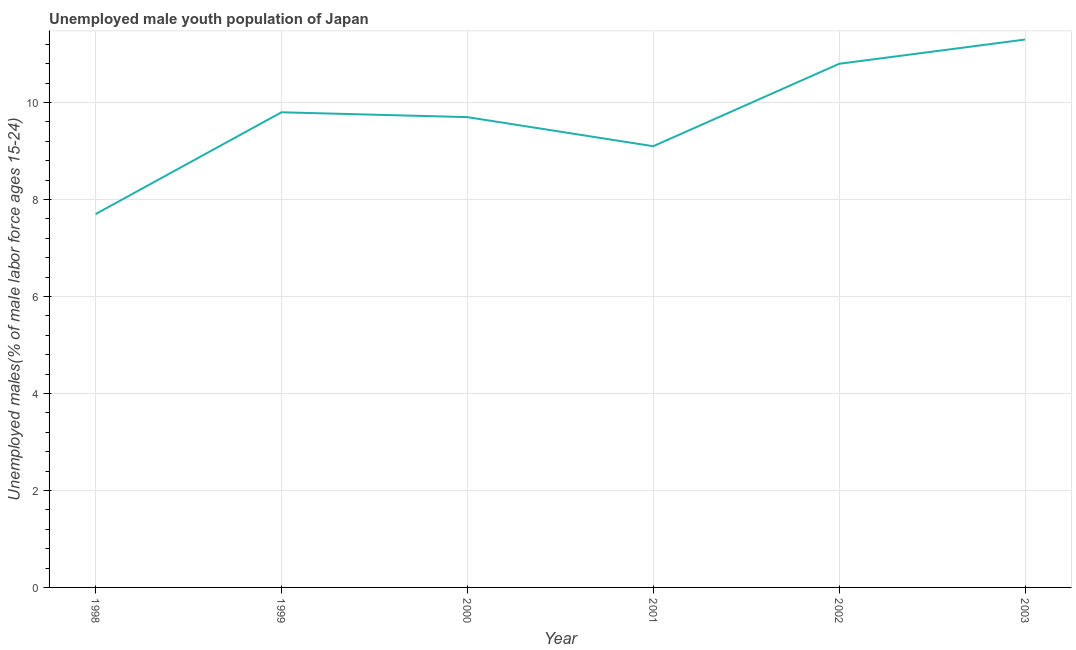What is the unemployed male youth in 2000?
Provide a short and direct response. 9.7. Across all years, what is the maximum unemployed male youth?
Keep it short and to the point. 11.3. Across all years, what is the minimum unemployed male youth?
Offer a terse response. 7.7. In which year was the unemployed male youth maximum?
Offer a terse response. 2003. In which year was the unemployed male youth minimum?
Make the answer very short. 1998. What is the sum of the unemployed male youth?
Provide a short and direct response. 58.4. What is the difference between the unemployed male youth in 1998 and 2000?
Provide a short and direct response. -2. What is the average unemployed male youth per year?
Your response must be concise. 9.73. What is the median unemployed male youth?
Give a very brief answer. 9.75. In how many years, is the unemployed male youth greater than 0.4 %?
Your response must be concise. 6. Do a majority of the years between 1999 and 2002 (inclusive) have unemployed male youth greater than 8.4 %?
Ensure brevity in your answer.  Yes. What is the ratio of the unemployed male youth in 2000 to that in 2002?
Provide a short and direct response. 0.9. Is the difference between the unemployed male youth in 2000 and 2002 greater than the difference between any two years?
Ensure brevity in your answer.  No. Is the sum of the unemployed male youth in 2000 and 2002 greater than the maximum unemployed male youth across all years?
Ensure brevity in your answer.  Yes. What is the difference between the highest and the lowest unemployed male youth?
Ensure brevity in your answer.  3.6. How many lines are there?
Your answer should be compact. 1. How many years are there in the graph?
Provide a succinct answer. 6. Are the values on the major ticks of Y-axis written in scientific E-notation?
Make the answer very short. No. Does the graph contain grids?
Provide a short and direct response. Yes. What is the title of the graph?
Offer a terse response. Unemployed male youth population of Japan. What is the label or title of the X-axis?
Your response must be concise. Year. What is the label or title of the Y-axis?
Provide a succinct answer. Unemployed males(% of male labor force ages 15-24). What is the Unemployed males(% of male labor force ages 15-24) of 1998?
Make the answer very short. 7.7. What is the Unemployed males(% of male labor force ages 15-24) in 1999?
Provide a succinct answer. 9.8. What is the Unemployed males(% of male labor force ages 15-24) of 2000?
Provide a succinct answer. 9.7. What is the Unemployed males(% of male labor force ages 15-24) in 2001?
Your answer should be compact. 9.1. What is the Unemployed males(% of male labor force ages 15-24) of 2002?
Your answer should be compact. 10.8. What is the Unemployed males(% of male labor force ages 15-24) of 2003?
Provide a short and direct response. 11.3. What is the difference between the Unemployed males(% of male labor force ages 15-24) in 1998 and 2000?
Your answer should be very brief. -2. What is the difference between the Unemployed males(% of male labor force ages 15-24) in 1998 and 2001?
Offer a very short reply. -1.4. What is the difference between the Unemployed males(% of male labor force ages 15-24) in 1998 and 2003?
Ensure brevity in your answer.  -3.6. What is the difference between the Unemployed males(% of male labor force ages 15-24) in 1999 and 2001?
Give a very brief answer. 0.7. What is the difference between the Unemployed males(% of male labor force ages 15-24) in 1999 and 2003?
Give a very brief answer. -1.5. What is the difference between the Unemployed males(% of male labor force ages 15-24) in 2000 and 2001?
Ensure brevity in your answer.  0.6. What is the difference between the Unemployed males(% of male labor force ages 15-24) in 2002 and 2003?
Give a very brief answer. -0.5. What is the ratio of the Unemployed males(% of male labor force ages 15-24) in 1998 to that in 1999?
Provide a short and direct response. 0.79. What is the ratio of the Unemployed males(% of male labor force ages 15-24) in 1998 to that in 2000?
Keep it short and to the point. 0.79. What is the ratio of the Unemployed males(% of male labor force ages 15-24) in 1998 to that in 2001?
Make the answer very short. 0.85. What is the ratio of the Unemployed males(% of male labor force ages 15-24) in 1998 to that in 2002?
Ensure brevity in your answer.  0.71. What is the ratio of the Unemployed males(% of male labor force ages 15-24) in 1998 to that in 2003?
Provide a short and direct response. 0.68. What is the ratio of the Unemployed males(% of male labor force ages 15-24) in 1999 to that in 2000?
Provide a succinct answer. 1.01. What is the ratio of the Unemployed males(% of male labor force ages 15-24) in 1999 to that in 2001?
Your answer should be very brief. 1.08. What is the ratio of the Unemployed males(% of male labor force ages 15-24) in 1999 to that in 2002?
Your answer should be compact. 0.91. What is the ratio of the Unemployed males(% of male labor force ages 15-24) in 1999 to that in 2003?
Your answer should be very brief. 0.87. What is the ratio of the Unemployed males(% of male labor force ages 15-24) in 2000 to that in 2001?
Offer a terse response. 1.07. What is the ratio of the Unemployed males(% of male labor force ages 15-24) in 2000 to that in 2002?
Make the answer very short. 0.9. What is the ratio of the Unemployed males(% of male labor force ages 15-24) in 2000 to that in 2003?
Your response must be concise. 0.86. What is the ratio of the Unemployed males(% of male labor force ages 15-24) in 2001 to that in 2002?
Give a very brief answer. 0.84. What is the ratio of the Unemployed males(% of male labor force ages 15-24) in 2001 to that in 2003?
Ensure brevity in your answer.  0.81. What is the ratio of the Unemployed males(% of male labor force ages 15-24) in 2002 to that in 2003?
Offer a very short reply. 0.96. 